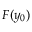Convert formula to latex. <formula><loc_0><loc_0><loc_500><loc_500>F ( y _ { 0 } )</formula> 